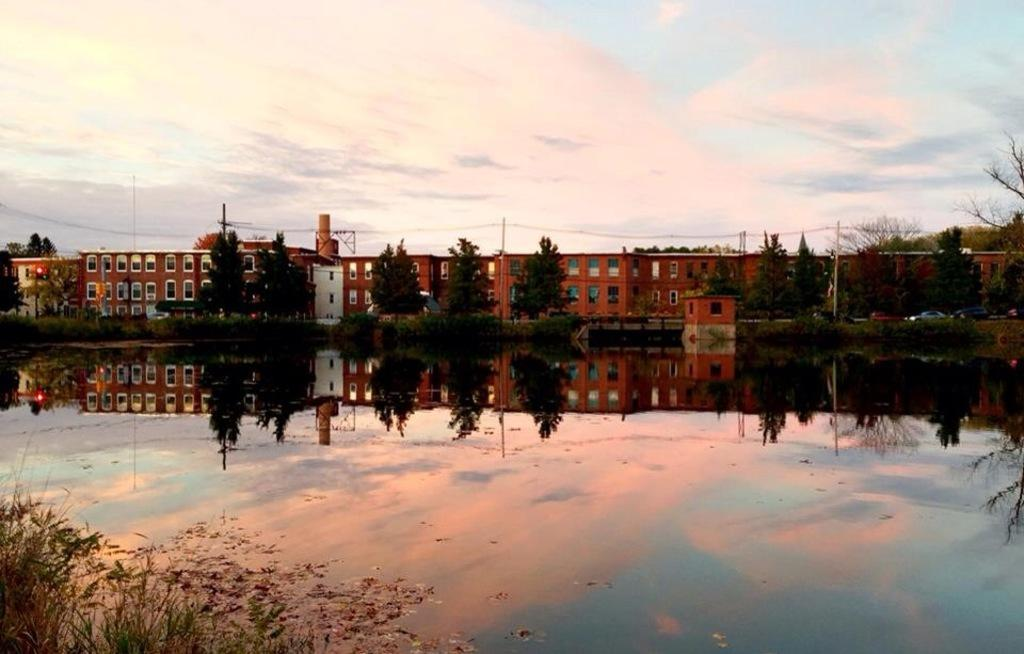What is visible in the image? Water is visible in the image. What can be seen in the background of the image? There are trees and buildings in the background of the image. What sense does the water evoke in the image? A: The image does not convey a sense of touch, taste, smell, or sound, so it is not possible to determine what sense the water evokes. 